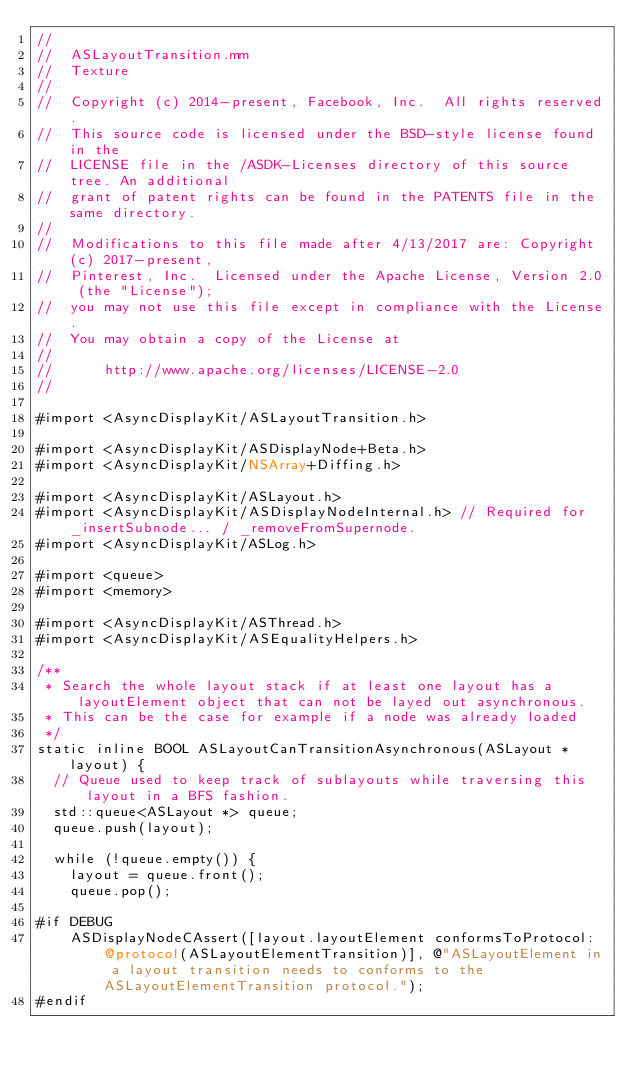Convert code to text. <code><loc_0><loc_0><loc_500><loc_500><_ObjectiveC_>//
//  ASLayoutTransition.mm
//  Texture
//
//  Copyright (c) 2014-present, Facebook, Inc.  All rights reserved.
//  This source code is licensed under the BSD-style license found in the
//  LICENSE file in the /ASDK-Licenses directory of this source tree. An additional
//  grant of patent rights can be found in the PATENTS file in the same directory.
//
//  Modifications to this file made after 4/13/2017 are: Copyright (c) 2017-present,
//  Pinterest, Inc.  Licensed under the Apache License, Version 2.0 (the "License");
//  you may not use this file except in compliance with the License.
//  You may obtain a copy of the License at
//
//      http://www.apache.org/licenses/LICENSE-2.0
//

#import <AsyncDisplayKit/ASLayoutTransition.h>

#import <AsyncDisplayKit/ASDisplayNode+Beta.h>
#import <AsyncDisplayKit/NSArray+Diffing.h>

#import <AsyncDisplayKit/ASLayout.h>
#import <AsyncDisplayKit/ASDisplayNodeInternal.h> // Required for _insertSubnode... / _removeFromSupernode.
#import <AsyncDisplayKit/ASLog.h>

#import <queue>
#import <memory>

#import <AsyncDisplayKit/ASThread.h>
#import <AsyncDisplayKit/ASEqualityHelpers.h>

/**
 * Search the whole layout stack if at least one layout has a layoutElement object that can not be layed out asynchronous.
 * This can be the case for example if a node was already loaded
 */
static inline BOOL ASLayoutCanTransitionAsynchronous(ASLayout *layout) {
  // Queue used to keep track of sublayouts while traversing this layout in a BFS fashion.
  std::queue<ASLayout *> queue;
  queue.push(layout);
  
  while (!queue.empty()) {
    layout = queue.front();
    queue.pop();
    
#if DEBUG
    ASDisplayNodeCAssert([layout.layoutElement conformsToProtocol:@protocol(ASLayoutElementTransition)], @"ASLayoutElement in a layout transition needs to conforms to the ASLayoutElementTransition protocol.");
#endif</code> 